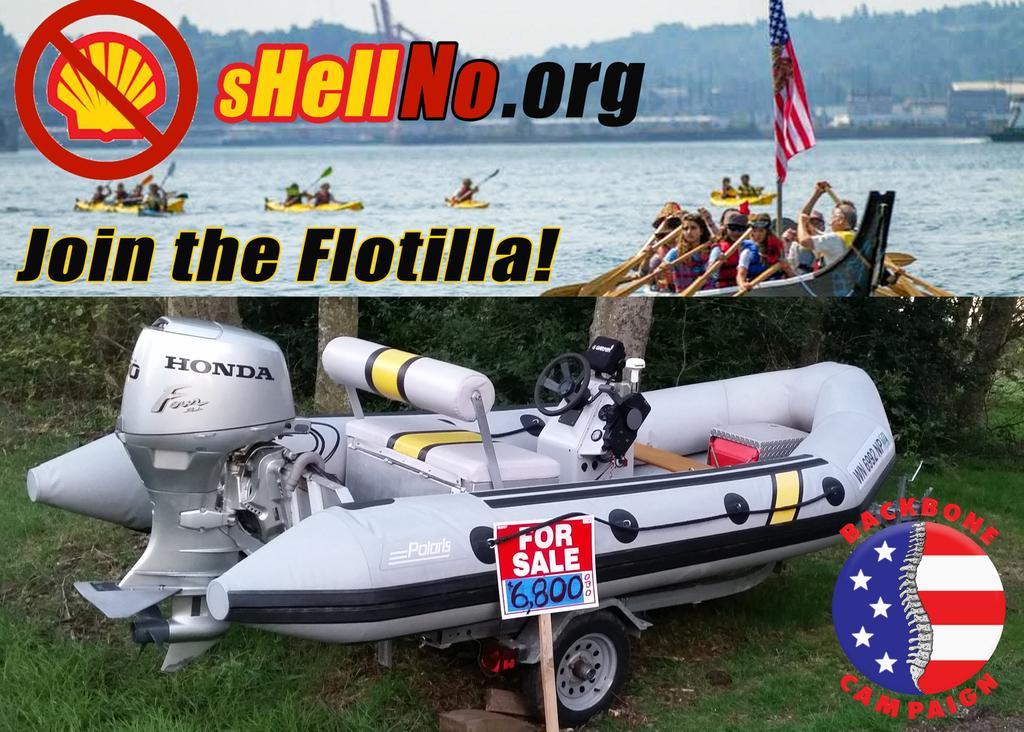In one or two sentences, can you explain what this image depicts? This is a collage, in this image at the bottom there is some boat, pole, board, grass, plants and some objects. And at the top of the image there is a river, and in the river there are some people who are paragliding and there is a text, flag, buildings, trees, and there is sky. 